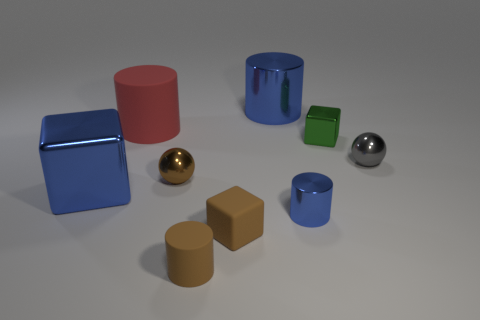Add 1 big cyan rubber blocks. How many objects exist? 10 Subtract all blue metal cubes. How many cubes are left? 2 Subtract all cyan balls. How many blue cylinders are left? 2 Subtract all balls. How many objects are left? 7 Subtract all red cylinders. How many cylinders are left? 3 Subtract 1 cylinders. How many cylinders are left? 3 Subtract all yellow cubes. Subtract all purple spheres. How many cubes are left? 3 Subtract all blocks. Subtract all tiny balls. How many objects are left? 4 Add 5 red rubber cylinders. How many red rubber cylinders are left? 6 Add 8 small gray objects. How many small gray objects exist? 9 